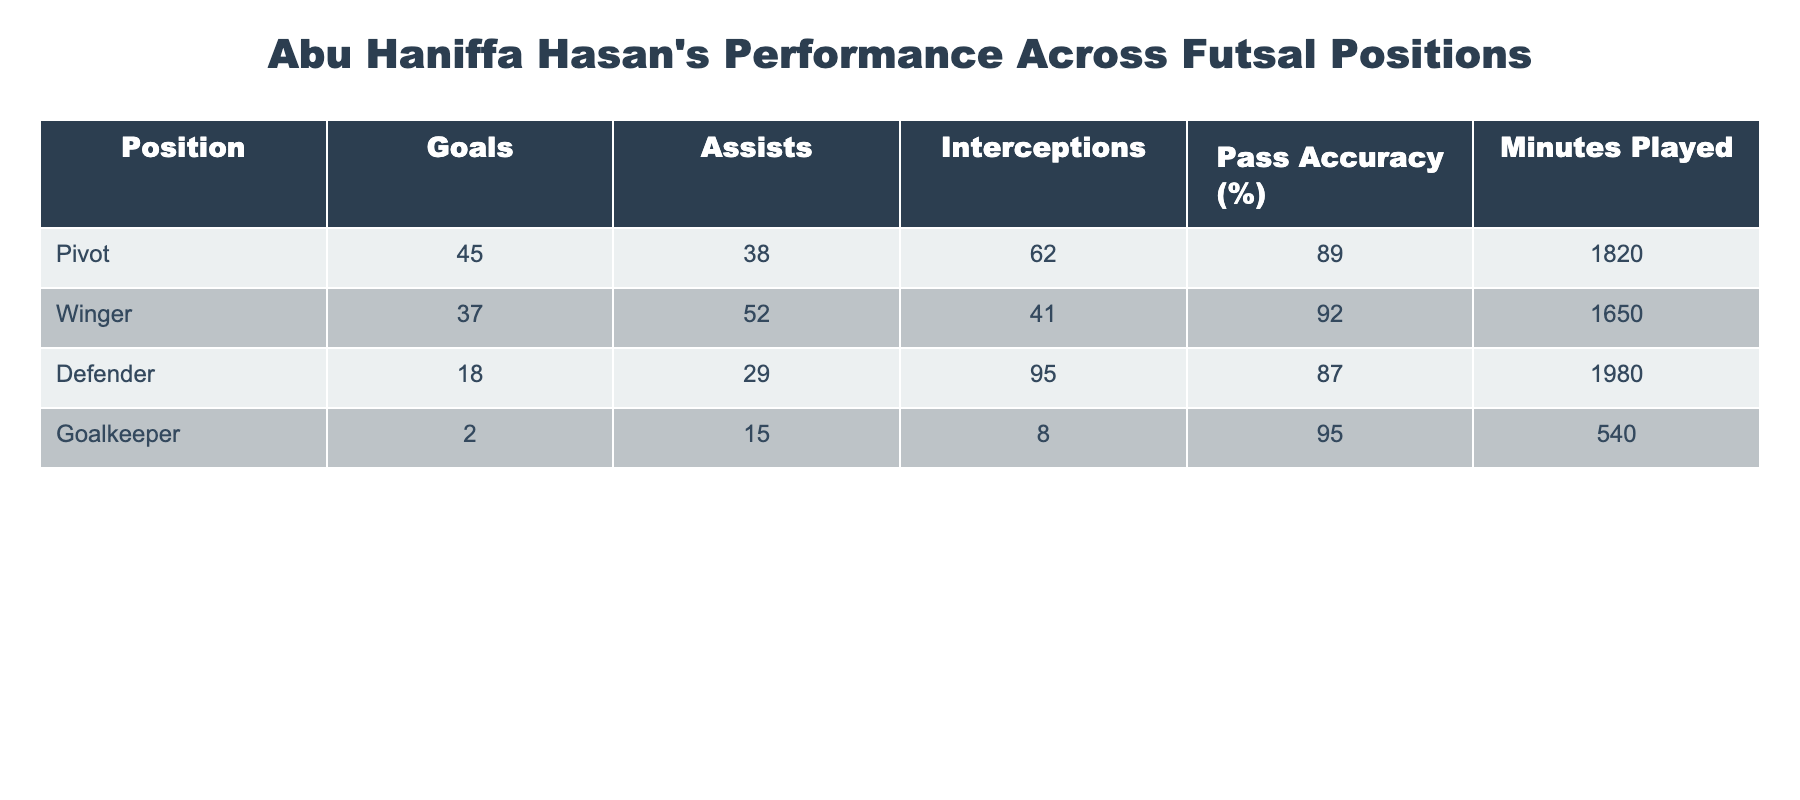What position scored the most goals? The table shows the number of goals scored by each position. The Pivot position has the highest goals at 45.
Answer: Pivot How many assists did the Winger provide? According to the table, the Winger provided a total of 52 assists.
Answer: 52 What is the average number of interceptions across all positions? Adding all interceptions: 62 (Pivot) + 41 (Winger) + 95 (Defender) + 8 (Goalkeeper) = 206. Then, dividing by the number of positions (4): 206 / 4 = 51.5.
Answer: 51.5 Did the Defender have a higher number of interceptions than the Winger? The Defender had 95 interceptions while the Winger had 41, so yes.
Answer: Yes What is the total number of goals and assists for the Goalkeeper? The Goalkeeper scored 2 goals and provided 15 assists. Adding these gives 2 + 15 = 17.
Answer: 17 Which position has the highest pass accuracy, and what is the percentage? The Goalkeeper has the highest pass accuracy at 95%.
Answer: Goalkeeper, 95% What position played the least number of minutes? Comparing the minutes played: Pivot (1820), Winger (1650), Defender (1980), Goalkeeper (540). The Goalkeeper played the least minutes at 540.
Answer: Goalkeeper If we compare the total impacts (goals + assists) of the Pivot and Defender, who had a greater impact? For the Pivot: 45 goals + 38 assists = 83 total impacts. For the Defender: 18 goals + 29 assists = 47 total impacts. Comparing 83 and 47, the Pivot had a greater impact.
Answer: Pivot Is the average pass accuracy for all positions above 90%? The averages are: (89 + 92 + 87 + 95) / 4 = 90.75%, which is above 90%.
Answer: Yes Which position contributed more assists, Winger or Defender? The Winger contributed 52 assists while the Defender contributed 29 assists. Thus, the Winger contributed more.
Answer: Winger 